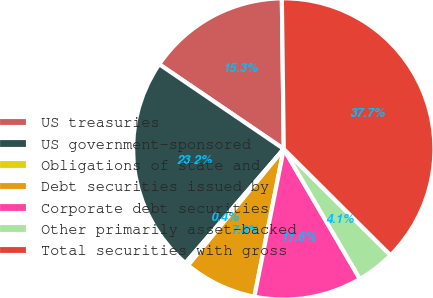Convert chart to OTSL. <chart><loc_0><loc_0><loc_500><loc_500><pie_chart><fcel>US treasuries<fcel>US government-sponsored<fcel>Obligations of state and<fcel>Debt securities issued by<fcel>Corporate debt securities<fcel>Other primarily asset-backed<fcel>Total securities with gross<nl><fcel>15.29%<fcel>23.18%<fcel>0.37%<fcel>7.83%<fcel>11.56%<fcel>4.1%<fcel>37.67%<nl></chart> 